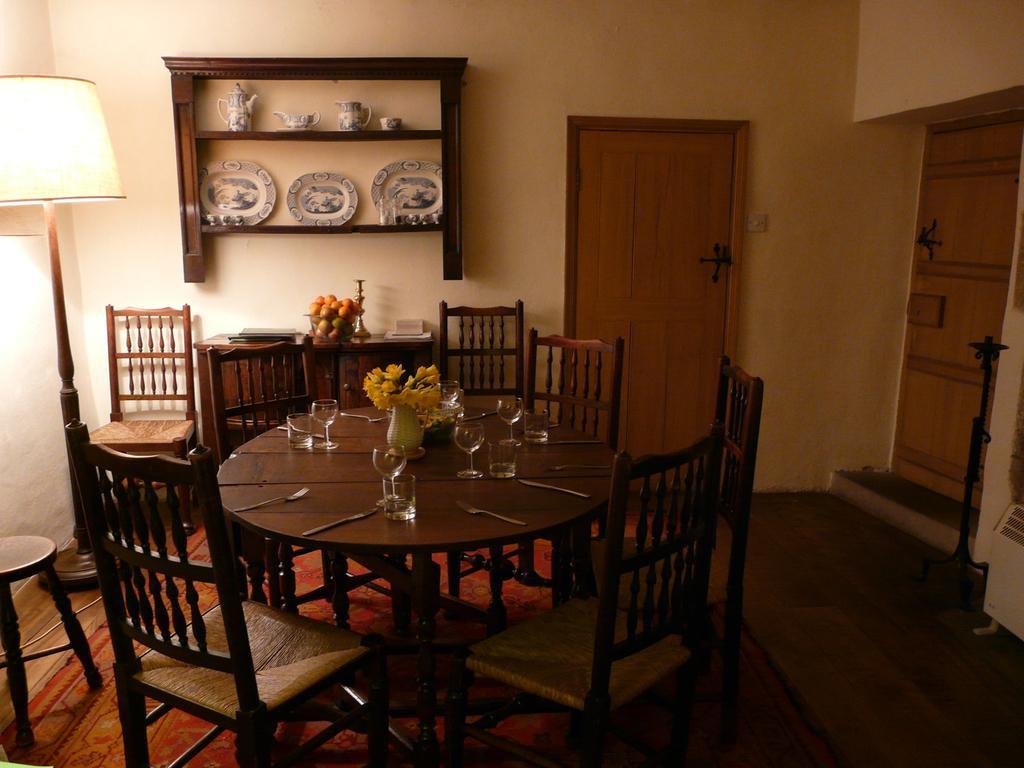In one or two sentences, can you explain what this image depicts? In this picture, there is a dining table in the center surrounded by the chairs. On the table, there are glass, forks and knife. In the center of the table, there is a flower vase. Towards the left, there is a lamp, stool and a chair. On the top, there is a shelf with plates, kettles etc. Below it, there is a desk. On the desk, there are some objects. Beside it, there is a door. Towards the right, there is another door. 